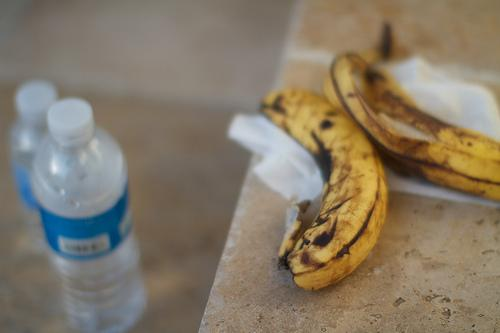Question: where is this scene?
Choices:
A. Kitchen counter.
B. Stone Mountain.
C. Niagra Falls.
D. Old Faithful.
Answer with the letter. Answer: A Question: what are these?
Choices:
A. Eggs.
B. Vegetables.
C. Fruits.
D. Bread.
Answer with the letter. Answer: C Question: what type of fruits are they?
Choices:
A. Apples.
B. Tomatoes.
C. Melons.
D. Bananas.
Answer with the letter. Answer: D 